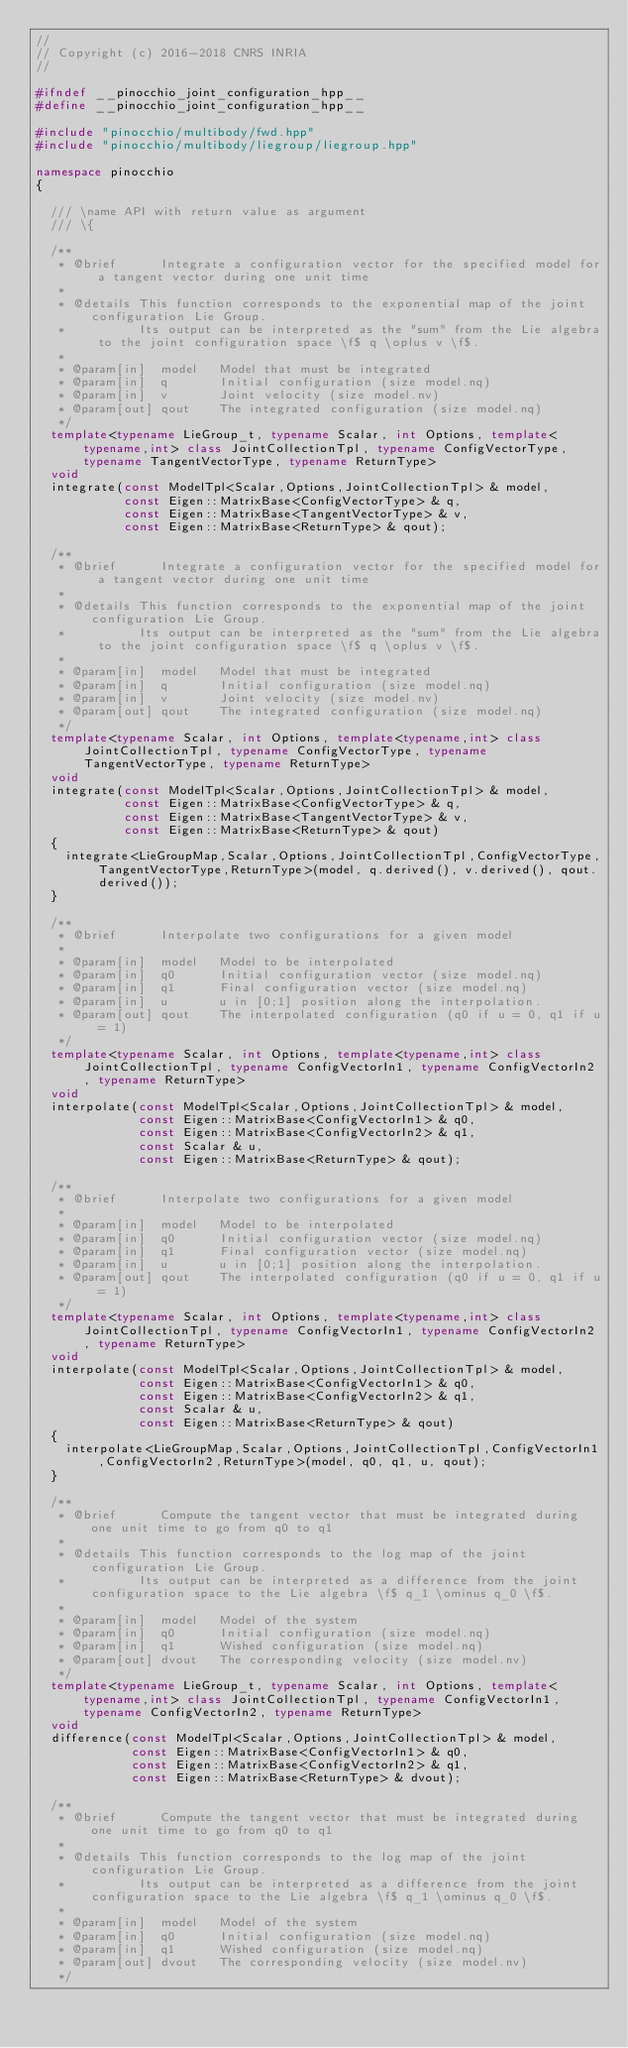<code> <loc_0><loc_0><loc_500><loc_500><_C++_>//
// Copyright (c) 2016-2018 CNRS INRIA
//

#ifndef __pinocchio_joint_configuration_hpp__
#define __pinocchio_joint_configuration_hpp__

#include "pinocchio/multibody/fwd.hpp"
#include "pinocchio/multibody/liegroup/liegroup.hpp"

namespace pinocchio
{

  /// \name API with return value as argument
  /// \{

  /**
   * @brief      Integrate a configuration vector for the specified model for a tangent vector during one unit time
   *
   * @details This function corresponds to the exponential map of the joint configuration Lie Group.
   *          Its output can be interpreted as the "sum" from the Lie algebra to the joint configuration space \f$ q \oplus v \f$.
   *
   * @param[in]  model   Model that must be integrated
   * @param[in]  q       Initial configuration (size model.nq)
   * @param[in]  v       Joint velocity (size model.nv)
   * @param[out] qout    The integrated configuration (size model.nq)
   */
  template<typename LieGroup_t, typename Scalar, int Options, template<typename,int> class JointCollectionTpl, typename ConfigVectorType, typename TangentVectorType, typename ReturnType>
  void
  integrate(const ModelTpl<Scalar,Options,JointCollectionTpl> & model,
            const Eigen::MatrixBase<ConfigVectorType> & q,
            const Eigen::MatrixBase<TangentVectorType> & v,
            const Eigen::MatrixBase<ReturnType> & qout);

  /**
   * @brief      Integrate a configuration vector for the specified model for a tangent vector during one unit time
   *
   * @details This function corresponds to the exponential map of the joint configuration Lie Group.
   *          Its output can be interpreted as the "sum" from the Lie algebra to the joint configuration space \f$ q \oplus v \f$.
   *
   * @param[in]  model   Model that must be integrated
   * @param[in]  q       Initial configuration (size model.nq)
   * @param[in]  v       Joint velocity (size model.nv)
   * @param[out] qout    The integrated configuration (size model.nq)
   */
  template<typename Scalar, int Options, template<typename,int> class JointCollectionTpl, typename ConfigVectorType, typename TangentVectorType, typename ReturnType>
  void
  integrate(const ModelTpl<Scalar,Options,JointCollectionTpl> & model,
            const Eigen::MatrixBase<ConfigVectorType> & q,
            const Eigen::MatrixBase<TangentVectorType> & v,
            const Eigen::MatrixBase<ReturnType> & qout)
  {
    integrate<LieGroupMap,Scalar,Options,JointCollectionTpl,ConfigVectorType,TangentVectorType,ReturnType>(model, q.derived(), v.derived(), qout.derived());
  }

  /**
   * @brief      Interpolate two configurations for a given model
   *
   * @param[in]  model   Model to be interpolated
   * @param[in]  q0      Initial configuration vector (size model.nq)
   * @param[in]  q1      Final configuration vector (size model.nq)
   * @param[in]  u       u in [0;1] position along the interpolation.
   * @param[out] qout    The interpolated configuration (q0 if u = 0, q1 if u = 1)
   */
  template<typename Scalar, int Options, template<typename,int> class JointCollectionTpl, typename ConfigVectorIn1, typename ConfigVectorIn2, typename ReturnType>
  void
  interpolate(const ModelTpl<Scalar,Options,JointCollectionTpl> & model,
              const Eigen::MatrixBase<ConfigVectorIn1> & q0,
              const Eigen::MatrixBase<ConfigVectorIn2> & q1,
              const Scalar & u,
              const Eigen::MatrixBase<ReturnType> & qout);

  /**
   * @brief      Interpolate two configurations for a given model
   *
   * @param[in]  model   Model to be interpolated
   * @param[in]  q0      Initial configuration vector (size model.nq)
   * @param[in]  q1      Final configuration vector (size model.nq)
   * @param[in]  u       u in [0;1] position along the interpolation.
   * @param[out] qout    The interpolated configuration (q0 if u = 0, q1 if u = 1)
   */
  template<typename Scalar, int Options, template<typename,int> class JointCollectionTpl, typename ConfigVectorIn1, typename ConfigVectorIn2, typename ReturnType>
  void
  interpolate(const ModelTpl<Scalar,Options,JointCollectionTpl> & model,
              const Eigen::MatrixBase<ConfigVectorIn1> & q0,
              const Eigen::MatrixBase<ConfigVectorIn2> & q1,
              const Scalar & u,
              const Eigen::MatrixBase<ReturnType> & qout)
  {
    interpolate<LieGroupMap,Scalar,Options,JointCollectionTpl,ConfigVectorIn1,ConfigVectorIn2,ReturnType>(model, q0, q1, u, qout);
  }

  /**
   * @brief      Compute the tangent vector that must be integrated during one unit time to go from q0 to q1
   *
   * @details This function corresponds to the log map of the joint configuration Lie Group.
   *          Its output can be interpreted as a difference from the joint configuration space to the Lie algebra \f$ q_1 \ominus q_0 \f$.
   *
   * @param[in]  model   Model of the system
   * @param[in]  q0      Initial configuration (size model.nq)
   * @param[in]  q1      Wished configuration (size model.nq)
   * @param[out] dvout   The corresponding velocity (size model.nv)
   */
  template<typename LieGroup_t, typename Scalar, int Options, template<typename,int> class JointCollectionTpl, typename ConfigVectorIn1, typename ConfigVectorIn2, typename ReturnType>
  void
  difference(const ModelTpl<Scalar,Options,JointCollectionTpl> & model,
             const Eigen::MatrixBase<ConfigVectorIn1> & q0,
             const Eigen::MatrixBase<ConfigVectorIn2> & q1,
             const Eigen::MatrixBase<ReturnType> & dvout);

  /**
   * @brief      Compute the tangent vector that must be integrated during one unit time to go from q0 to q1
   *
   * @details This function corresponds to the log map of the joint configuration Lie Group.
   *          Its output can be interpreted as a difference from the joint configuration space to the Lie algebra \f$ q_1 \ominus q_0 \f$.
   *
   * @param[in]  model   Model of the system
   * @param[in]  q0      Initial configuration (size model.nq)
   * @param[in]  q1      Wished configuration (size model.nq)
   * @param[out] dvout   The corresponding velocity (size model.nv)
   */</code> 